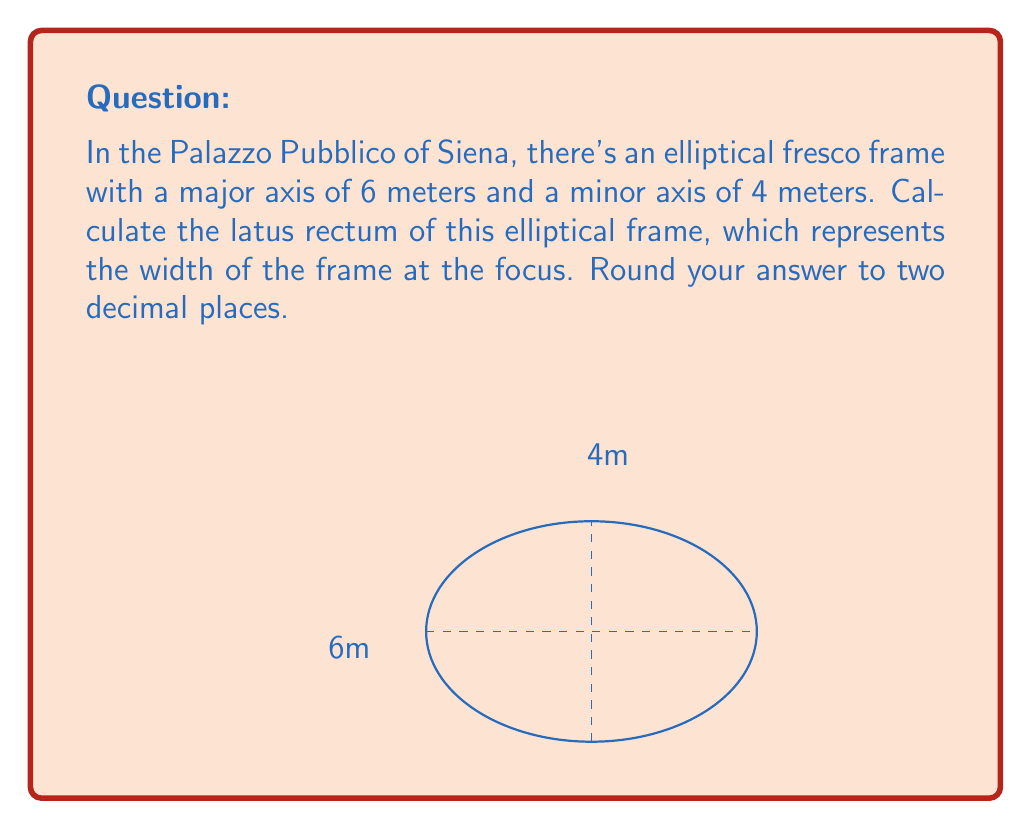Teach me how to tackle this problem. Let's approach this step-by-step:

1) The latus rectum of an ellipse is the chord that passes through a focus and is perpendicular to the major axis. Its length is given by the formula:

   $$ L = \frac{2b^2}{a} $$

   where $L$ is the latus rectum, $a$ is the semi-major axis, and $b$ is the semi-minor axis.

2) From the given information:
   - Major axis = 6 meters, so $a = 3$ meters
   - Minor axis = 4 meters, so $b = 2$ meters

3) Substituting these values into our formula:

   $$ L = \frac{2(2^2)}{3} $$

4) Simplify:
   $$ L = \frac{2(4)}{3} = \frac{8}{3} $$

5) Calculate:
   $$ L \approx 2.6666... $$

6) Rounding to two decimal places:
   $$ L \approx 2.67 \text{ meters} $$

This result represents the width of the elliptical fresco frame at its focus, a key characteristic of elliptical shapes in Renaissance art and architecture.
Answer: 2.67 meters 